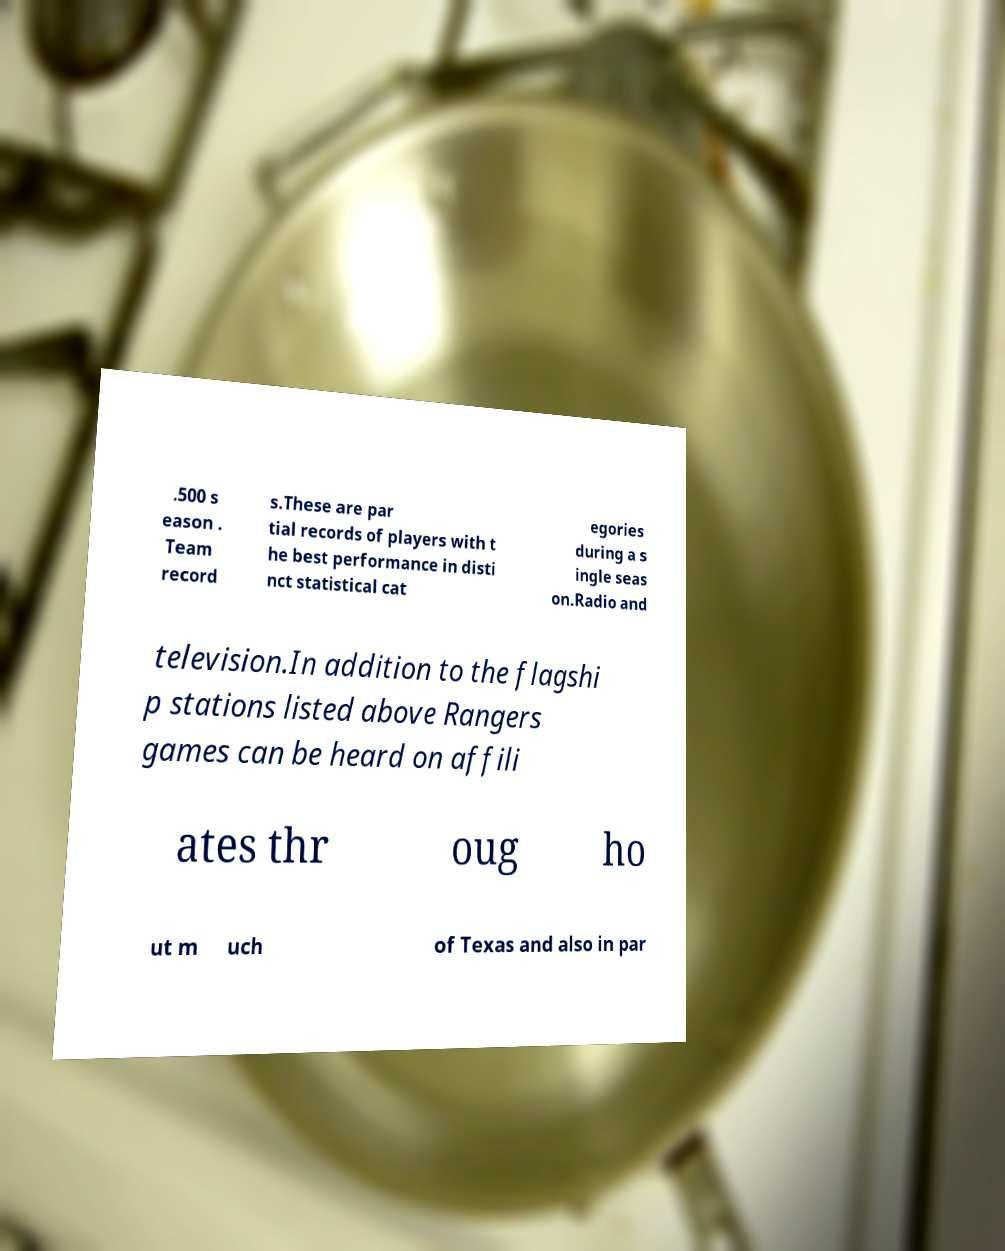Could you assist in decoding the text presented in this image and type it out clearly? .500 s eason . Team record s.These are par tial records of players with t he best performance in disti nct statistical cat egories during a s ingle seas on.Radio and television.In addition to the flagshi p stations listed above Rangers games can be heard on affili ates thr oug ho ut m uch of Texas and also in par 